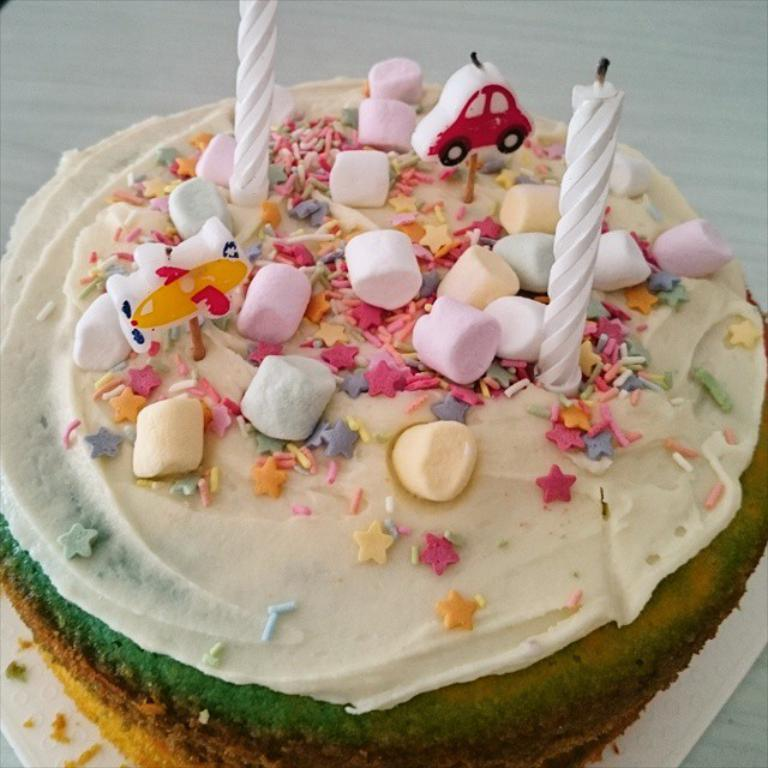What is the main subject of the image? There is a cake in the image. How can you describe the appearance of the cake? The cake has multiple colors. Are there any decorations on the cake? Yes, there are two candles on the cake. What type of chicken is sitting on top of the cake in the image? There is no chicken present on the cake or in the image. 